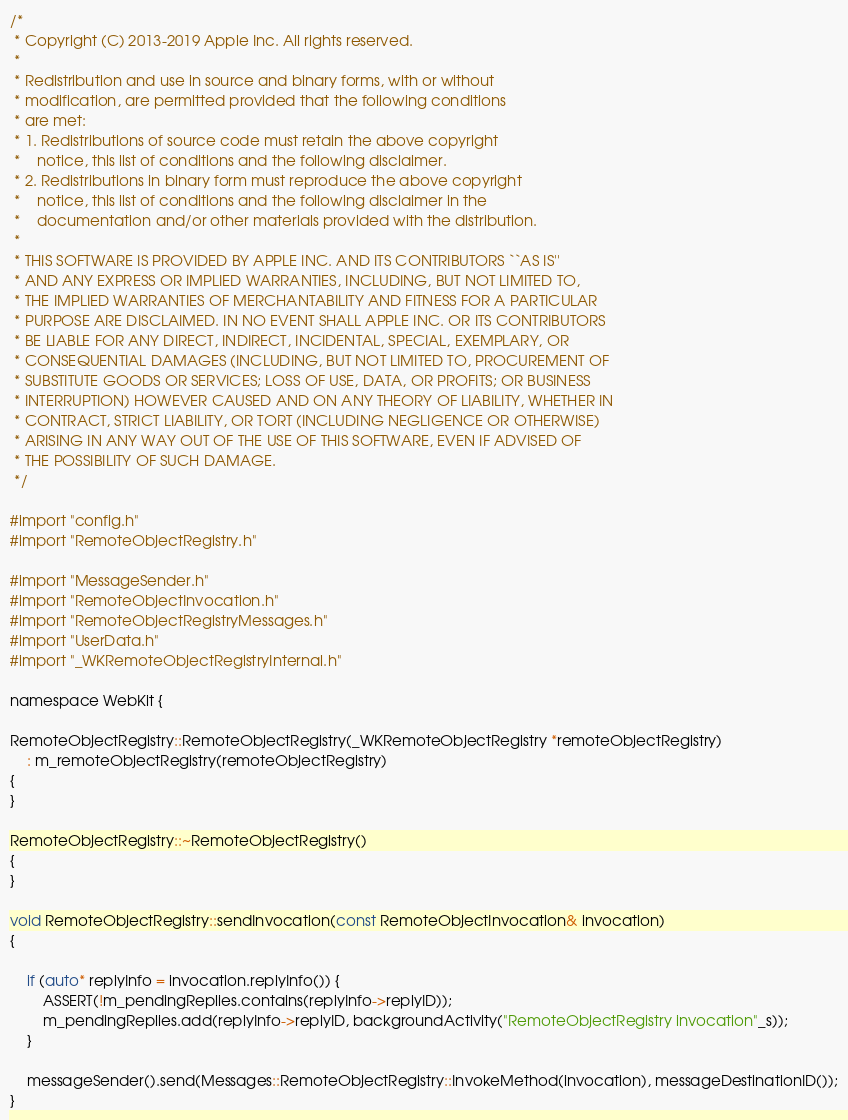Convert code to text. <code><loc_0><loc_0><loc_500><loc_500><_ObjectiveC_>/*
 * Copyright (C) 2013-2019 Apple Inc. All rights reserved.
 *
 * Redistribution and use in source and binary forms, with or without
 * modification, are permitted provided that the following conditions
 * are met:
 * 1. Redistributions of source code must retain the above copyright
 *    notice, this list of conditions and the following disclaimer.
 * 2. Redistributions in binary form must reproduce the above copyright
 *    notice, this list of conditions and the following disclaimer in the
 *    documentation and/or other materials provided with the distribution.
 *
 * THIS SOFTWARE IS PROVIDED BY APPLE INC. AND ITS CONTRIBUTORS ``AS IS''
 * AND ANY EXPRESS OR IMPLIED WARRANTIES, INCLUDING, BUT NOT LIMITED TO,
 * THE IMPLIED WARRANTIES OF MERCHANTABILITY AND FITNESS FOR A PARTICULAR
 * PURPOSE ARE DISCLAIMED. IN NO EVENT SHALL APPLE INC. OR ITS CONTRIBUTORS
 * BE LIABLE FOR ANY DIRECT, INDIRECT, INCIDENTAL, SPECIAL, EXEMPLARY, OR
 * CONSEQUENTIAL DAMAGES (INCLUDING, BUT NOT LIMITED TO, PROCUREMENT OF
 * SUBSTITUTE GOODS OR SERVICES; LOSS OF USE, DATA, OR PROFITS; OR BUSINESS
 * INTERRUPTION) HOWEVER CAUSED AND ON ANY THEORY OF LIABILITY, WHETHER IN
 * CONTRACT, STRICT LIABILITY, OR TORT (INCLUDING NEGLIGENCE OR OTHERWISE)
 * ARISING IN ANY WAY OUT OF THE USE OF THIS SOFTWARE, EVEN IF ADVISED OF
 * THE POSSIBILITY OF SUCH DAMAGE.
 */

#import "config.h"
#import "RemoteObjectRegistry.h"

#import "MessageSender.h"
#import "RemoteObjectInvocation.h"
#import "RemoteObjectRegistryMessages.h"
#import "UserData.h"
#import "_WKRemoteObjectRegistryInternal.h"

namespace WebKit {

RemoteObjectRegistry::RemoteObjectRegistry(_WKRemoteObjectRegistry *remoteObjectRegistry)
    : m_remoteObjectRegistry(remoteObjectRegistry)
{
}

RemoteObjectRegistry::~RemoteObjectRegistry()
{
}

void RemoteObjectRegistry::sendInvocation(const RemoteObjectInvocation& invocation)
{

    if (auto* replyInfo = invocation.replyInfo()) {
        ASSERT(!m_pendingReplies.contains(replyInfo->replyID));
        m_pendingReplies.add(replyInfo->replyID, backgroundActivity("RemoteObjectRegistry invocation"_s));
    }

    messageSender().send(Messages::RemoteObjectRegistry::InvokeMethod(invocation), messageDestinationID());
}
</code> 